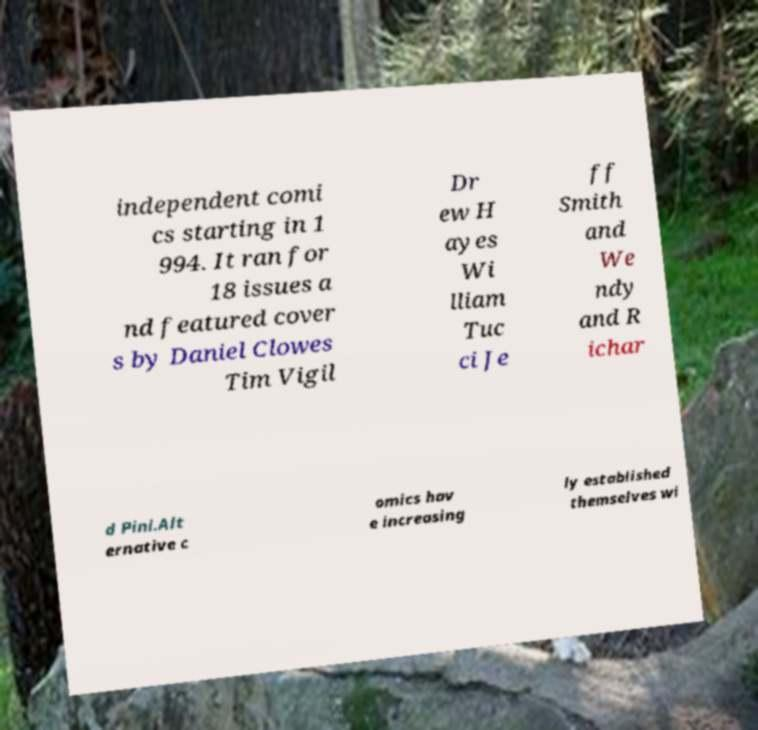Please read and relay the text visible in this image. What does it say? independent comi cs starting in 1 994. It ran for 18 issues a nd featured cover s by Daniel Clowes Tim Vigil Dr ew H ayes Wi lliam Tuc ci Je ff Smith and We ndy and R ichar d Pini.Alt ernative c omics hav e increasing ly established themselves wi 